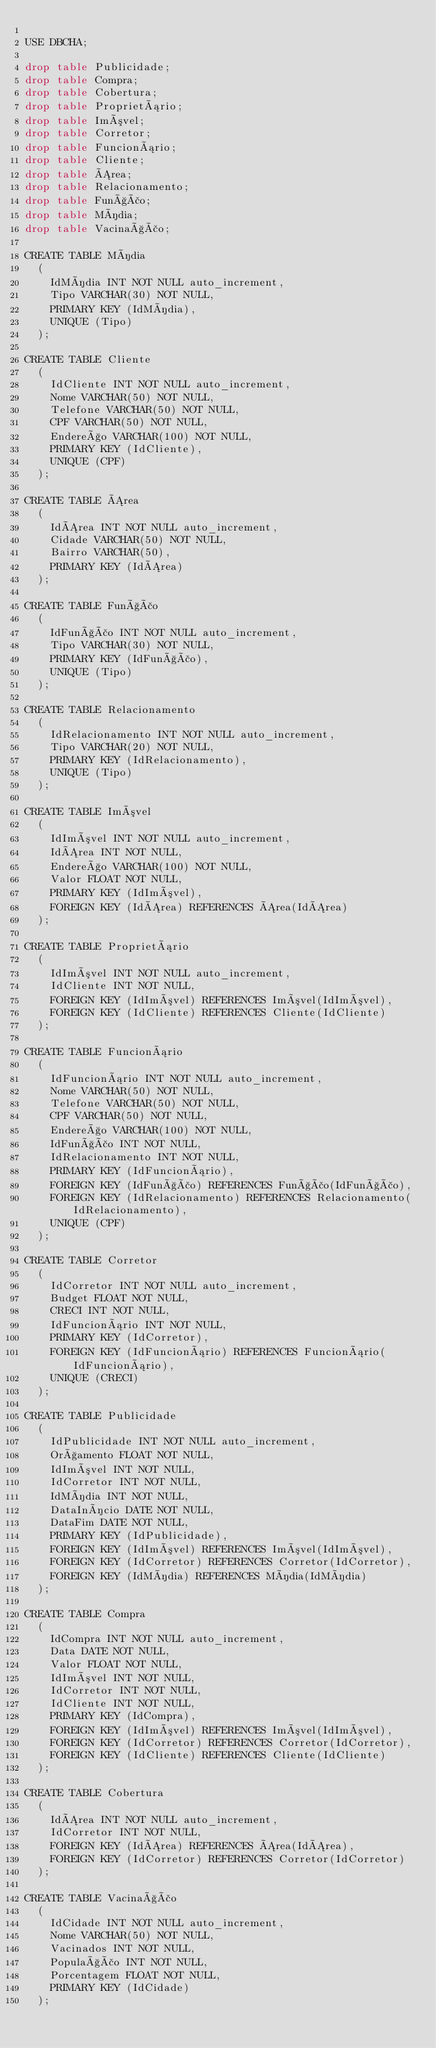<code> <loc_0><loc_0><loc_500><loc_500><_SQL_>
USE DBCHA;

drop table Publicidade;
drop table Compra;
drop table Cobertura;
drop table Proprietário;
drop table Imóvel;
drop table Corretor;
drop table Funcionário;
drop table Cliente;
drop table Área;
drop table Relacionamento;
drop table Função;
drop table Mídia;
drop table Vacinação;

CREATE TABLE Mídia
  (
    IdMídia INT NOT NULL auto_increment,
    Tipo VARCHAR(30) NOT NULL,
    PRIMARY KEY (IdMídia),
    UNIQUE (Tipo)
  );

CREATE TABLE Cliente
  (
    IdCliente INT NOT NULL auto_increment,
    Nome VARCHAR(50) NOT NULL,
    Telefone VARCHAR(50) NOT NULL,
    CPF VARCHAR(50) NOT NULL,
    Endereço VARCHAR(100) NOT NULL,
    PRIMARY KEY (IdCliente),
    UNIQUE (CPF)
  );

CREATE TABLE Área
  (
    IdÁrea INT NOT NULL auto_increment,
    Cidade VARCHAR(50) NOT NULL,
    Bairro VARCHAR(50),
    PRIMARY KEY (IdÁrea)
  );

CREATE TABLE Função
  (
    IdFunção INT NOT NULL auto_increment,
    Tipo VARCHAR(30) NOT NULL,
    PRIMARY KEY (IdFunção),
    UNIQUE (Tipo)
  );

CREATE TABLE Relacionamento
  (
    IdRelacionamento INT NOT NULL auto_increment,
    Tipo VARCHAR(20) NOT NULL,
    PRIMARY KEY (IdRelacionamento),
    UNIQUE (Tipo)
  );

CREATE TABLE Imóvel
  (
    IdImóvel INT NOT NULL auto_increment,
    IdÁrea INT NOT NULL,
    Endereço VARCHAR(100) NOT NULL,
    Valor FLOAT NOT NULL,
    PRIMARY KEY (IdImóvel),
    FOREIGN KEY (IdÁrea) REFERENCES Área(IdÁrea)
  );

CREATE TABLE Proprietário
  (
    IdImóvel INT NOT NULL auto_increment,
    IdCliente INT NOT NULL,
    FOREIGN KEY (IdImóvel) REFERENCES Imóvel(IdImóvel),
    FOREIGN KEY (IdCliente) REFERENCES Cliente(IdCliente)
  );

CREATE TABLE Funcionário
  (
    IdFuncionário INT NOT NULL auto_increment,
    Nome VARCHAR(50) NOT NULL,
    Telefone VARCHAR(50) NOT NULL,
    CPF VARCHAR(50) NOT NULL,
    Endereço VARCHAR(100) NOT NULL,
    IdFunção INT NOT NULL,
    IdRelacionamento INT NOT NULL,
    PRIMARY KEY (IdFuncionário),
    FOREIGN KEY (IdFunção) REFERENCES Função(IdFunção),
    FOREIGN KEY (IdRelacionamento) REFERENCES Relacionamento(IdRelacionamento),
    UNIQUE (CPF)
  );

CREATE TABLE Corretor
  (
    IdCorretor INT NOT NULL auto_increment,
    Budget FLOAT NOT NULL,
    CRECI INT NOT NULL,
    IdFuncionário INT NOT NULL,
    PRIMARY KEY (IdCorretor),
    FOREIGN KEY (IdFuncionário) REFERENCES Funcionário(IdFuncionário),
    UNIQUE (CRECI)
  );

CREATE TABLE Publicidade
  (
    IdPublicidade INT NOT NULL auto_increment,
    Orçamento FLOAT NOT NULL,
    IdImóvel INT NOT NULL,
    IdCorretor INT NOT NULL,
    IdMídia INT NOT NULL,
    DataInício DATE NOT NULL,
    DataFim DATE NOT NULL,
    PRIMARY KEY (IdPublicidade),
    FOREIGN KEY (IdImóvel) REFERENCES Imóvel(IdImóvel),
    FOREIGN KEY (IdCorretor) REFERENCES Corretor(IdCorretor),
    FOREIGN KEY (IdMídia) REFERENCES Mídia(IdMídia)
  );

CREATE TABLE Compra
  (
    IdCompra INT NOT NULL auto_increment,
    Data DATE NOT NULL,
    Valor FLOAT NOT NULL,
    IdImóvel INT NOT NULL,
    IdCorretor INT NOT NULL,
    IdCliente INT NOT NULL,
    PRIMARY KEY (IdCompra),
    FOREIGN KEY (IdImóvel) REFERENCES Imóvel(IdImóvel),
    FOREIGN KEY (IdCorretor) REFERENCES Corretor(IdCorretor),
    FOREIGN KEY (IdCliente) REFERENCES Cliente(IdCliente)
  );

CREATE TABLE Cobertura
  (
    IdÁrea INT NOT NULL auto_increment,
    IdCorretor INT NOT NULL,
    FOREIGN KEY (IdÁrea) REFERENCES Área(IdÁrea),
    FOREIGN KEY (IdCorretor) REFERENCES Corretor(IdCorretor)
  );

CREATE TABLE Vacinação
  (
    IdCidade INT NOT NULL auto_increment,
    Nome VARCHAR(50) NOT NULL,
    Vacinados INT NOT NULL,
    População INT NOT NULL,
    Porcentagem FLOAT NOT NULL,
    PRIMARY KEY (IdCidade)
  );
</code> 